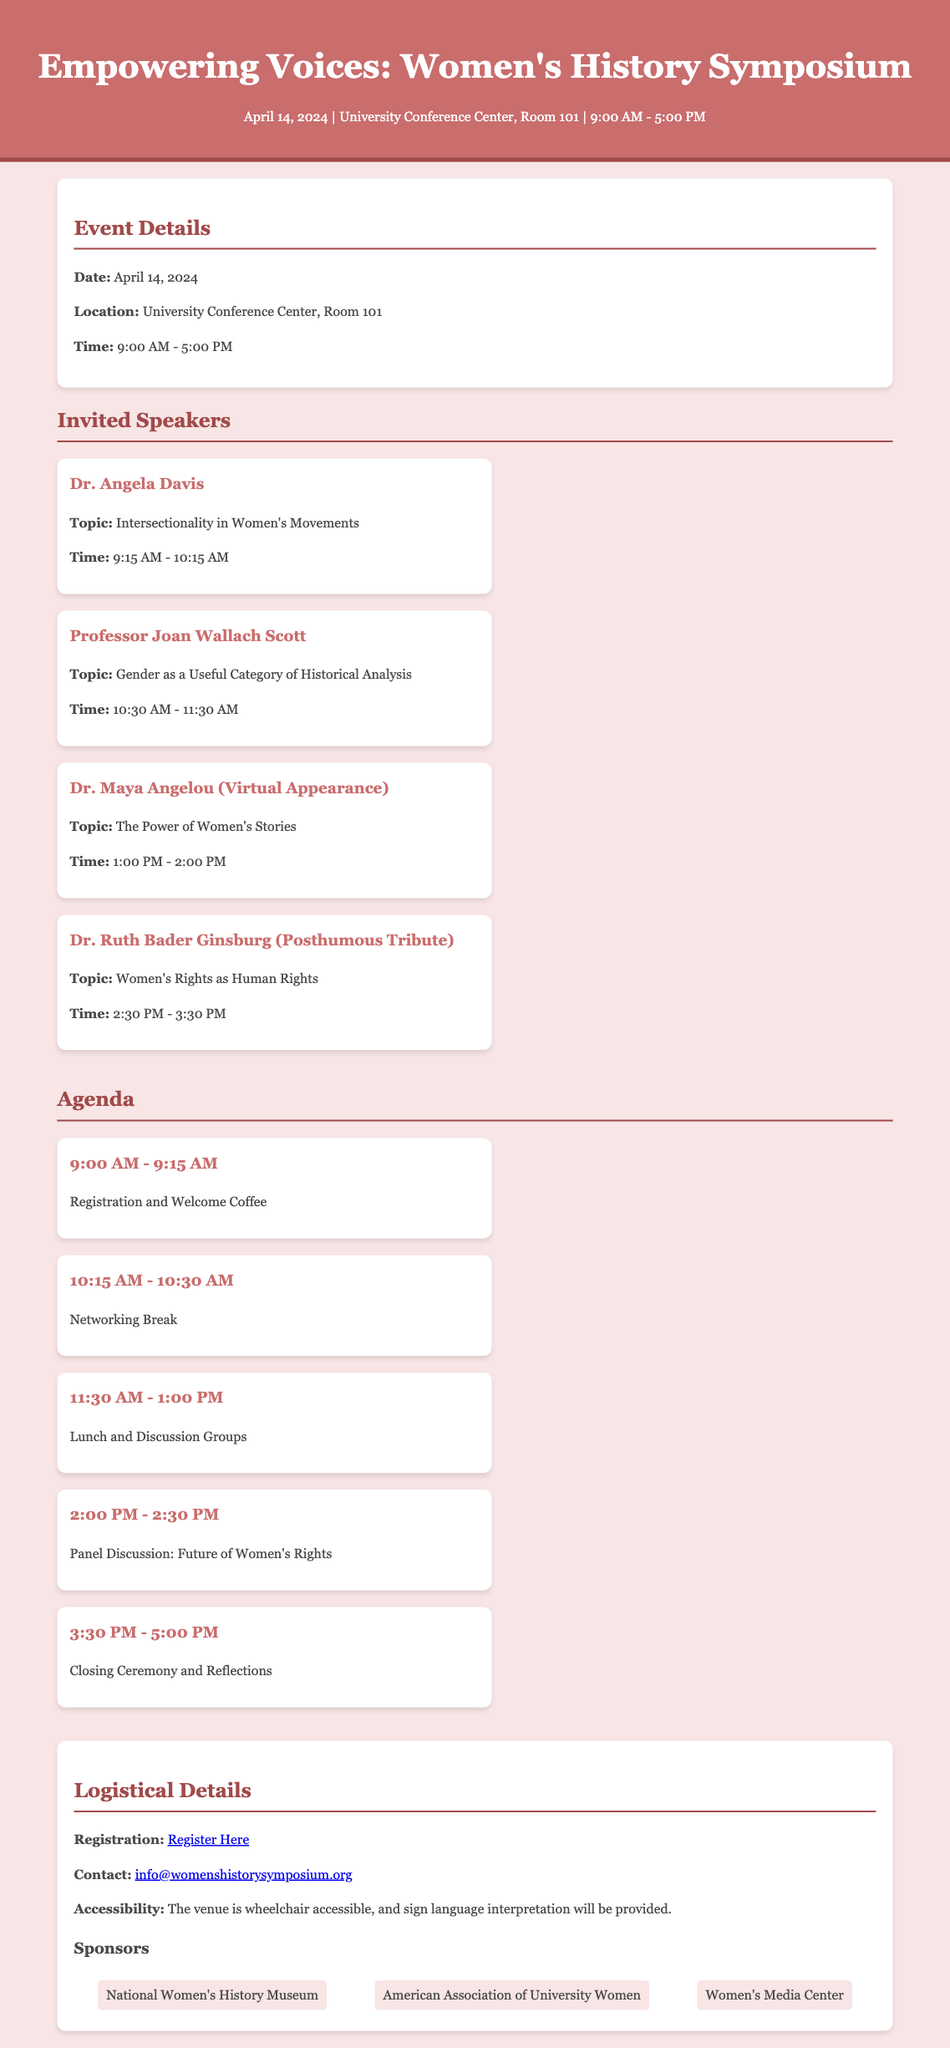What is the date of the symposium? The date of the symposium is mentioned in the event details section.
Answer: April 14, 2024 Who is one of the invited speakers? The document lists several invited speakers, including prominent individuals.
Answer: Dr. Angela Davis What is the venue for the event? The location of the symposium is specified in the event details section.
Answer: University Conference Center, Room 101 What is the time for lunch and discussion groups? The agenda provides timing for specific activities during the symposium.
Answer: 11:30 AM - 1:00 PM What topic will Dr. Maya Angelou discuss? The document includes topics for each invited speaker.
Answer: The Power of Women's Stories How long is the closing ceremony scheduled for? The agenda lists the starting and ending times for the closing ceremony.
Answer: 1.5 hours What type of contact information is provided? The logistical details section includes a specific form of contact information.
Answer: Email What organization is one of the sponsors? The sponsors' section lists organizations supporting the event.
Answer: National Women's History Museum Is the venue accessible? The logistical details section mentions specifics regarding accessibility.
Answer: Yes 